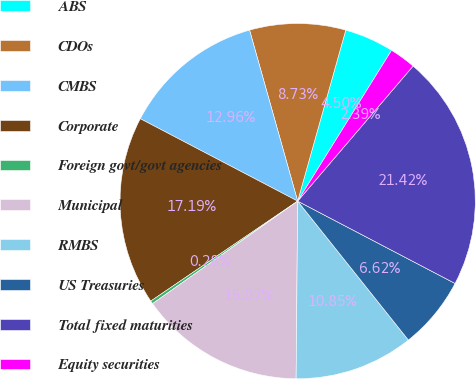<chart> <loc_0><loc_0><loc_500><loc_500><pie_chart><fcel>ABS<fcel>CDOs<fcel>CMBS<fcel>Corporate<fcel>Foreign govt/govt agencies<fcel>Municipal<fcel>RMBS<fcel>US Treasuries<fcel>Total fixed maturities<fcel>Equity securities<nl><fcel>4.5%<fcel>8.73%<fcel>12.96%<fcel>17.19%<fcel>0.28%<fcel>15.07%<fcel>10.85%<fcel>6.62%<fcel>21.42%<fcel>2.39%<nl></chart> 